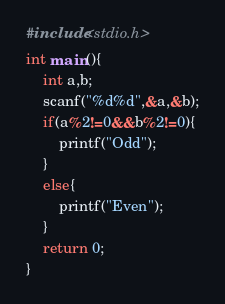<code> <loc_0><loc_0><loc_500><loc_500><_C_>#include<stdio.h>
int main(){
	int a,b;
	scanf("%d%d",&a,&b);
	if(a%2!=0&&b%2!=0){
		printf("Odd");
	}
	else{
		printf("Even");
	}
	return 0;
}
</code> 